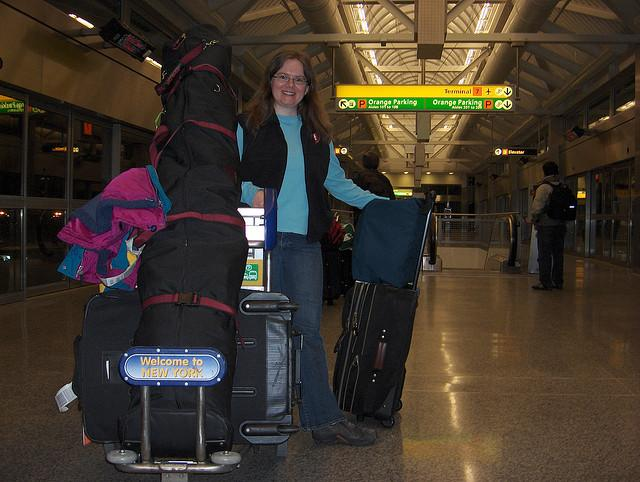What color are the straps wrapping up the black duffel on the luggage rack? red 